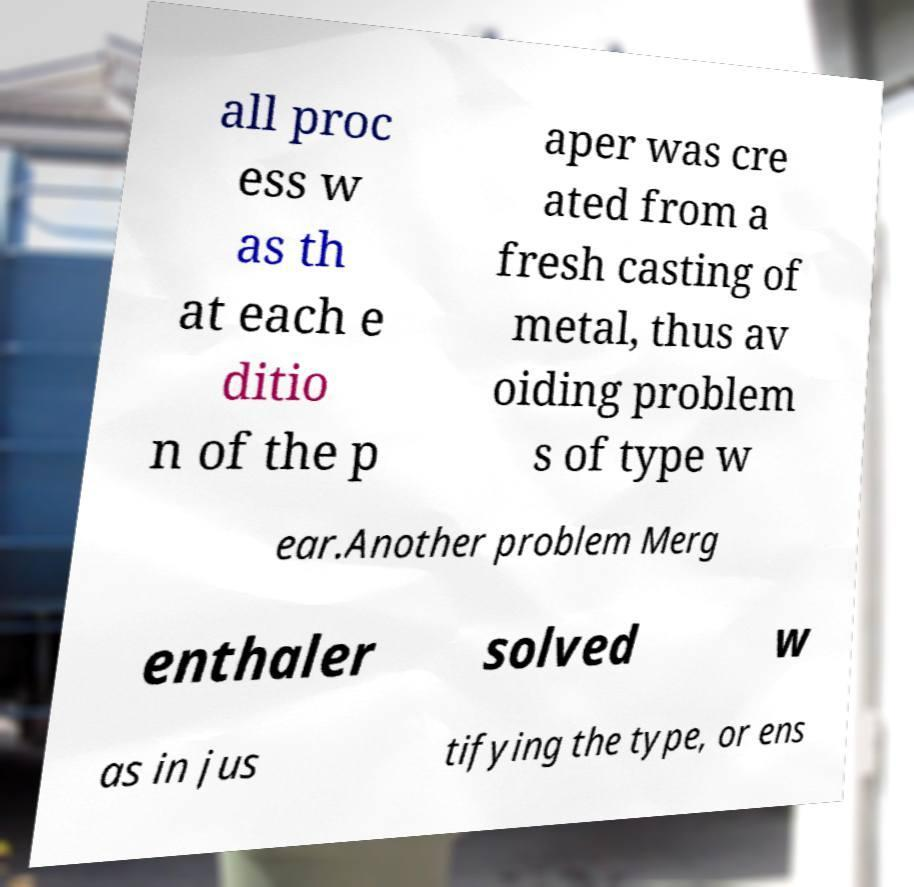Could you assist in decoding the text presented in this image and type it out clearly? all proc ess w as th at each e ditio n of the p aper was cre ated from a fresh casting of metal, thus av oiding problem s of type w ear.Another problem Merg enthaler solved w as in jus tifying the type, or ens 